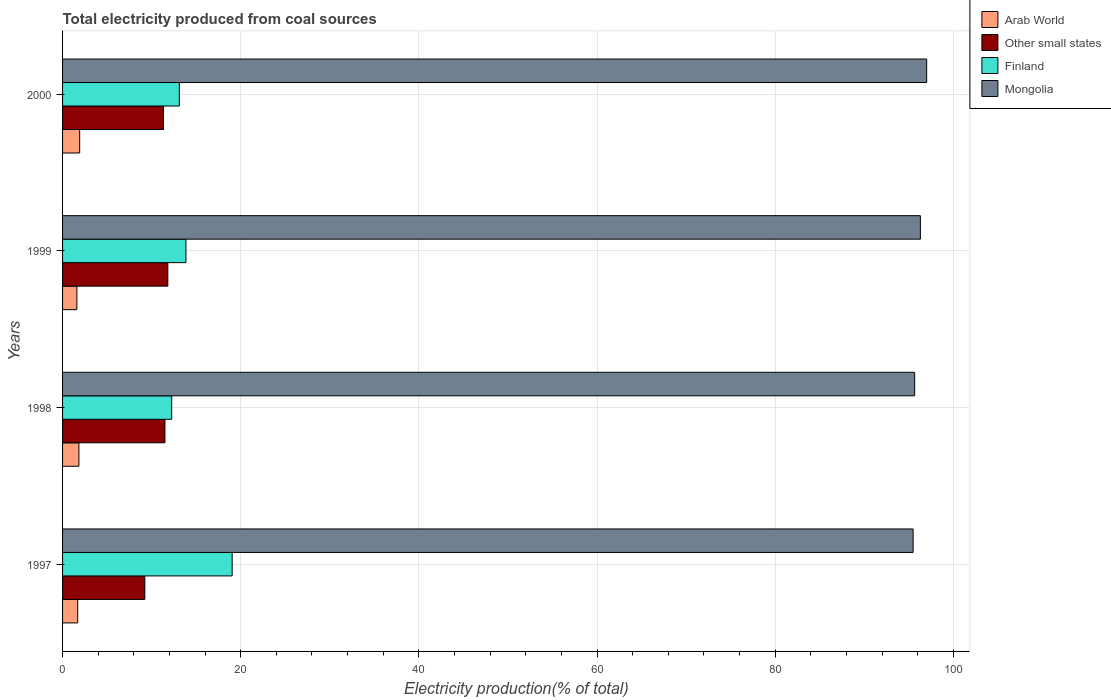How many different coloured bars are there?
Make the answer very short. 4. How many groups of bars are there?
Offer a terse response. 4. Are the number of bars per tick equal to the number of legend labels?
Provide a succinct answer. Yes. How many bars are there on the 1st tick from the bottom?
Provide a succinct answer. 4. What is the label of the 3rd group of bars from the top?
Your response must be concise. 1998. In how many cases, is the number of bars for a given year not equal to the number of legend labels?
Give a very brief answer. 0. What is the total electricity produced in Other small states in 1999?
Provide a short and direct response. 11.82. Across all years, what is the maximum total electricity produced in Finland?
Your answer should be compact. 19.04. Across all years, what is the minimum total electricity produced in Other small states?
Provide a succinct answer. 9.24. In which year was the total electricity produced in Arab World maximum?
Offer a terse response. 2000. In which year was the total electricity produced in Finland minimum?
Offer a terse response. 1998. What is the total total electricity produced in Other small states in the graph?
Make the answer very short. 43.88. What is the difference between the total electricity produced in Arab World in 1997 and that in 1998?
Your answer should be very brief. -0.14. What is the difference between the total electricity produced in Mongolia in 2000 and the total electricity produced in Finland in 1997?
Provide a short and direct response. 77.97. What is the average total electricity produced in Finland per year?
Your answer should be compact. 14.56. In the year 1997, what is the difference between the total electricity produced in Arab World and total electricity produced in Finland?
Give a very brief answer. -17.34. What is the ratio of the total electricity produced in Arab World in 1997 to that in 2000?
Provide a short and direct response. 0.88. Is the difference between the total electricity produced in Arab World in 1998 and 2000 greater than the difference between the total electricity produced in Finland in 1998 and 2000?
Give a very brief answer. Yes. What is the difference between the highest and the second highest total electricity produced in Other small states?
Provide a short and direct response. 0.32. What is the difference between the highest and the lowest total electricity produced in Finland?
Offer a terse response. 6.79. Is the sum of the total electricity produced in Mongolia in 1997 and 1998 greater than the maximum total electricity produced in Other small states across all years?
Keep it short and to the point. Yes. What does the 1st bar from the top in 2000 represents?
Provide a succinct answer. Mongolia. What does the 4th bar from the bottom in 2000 represents?
Provide a succinct answer. Mongolia. What is the difference between two consecutive major ticks on the X-axis?
Give a very brief answer. 20. Are the values on the major ticks of X-axis written in scientific E-notation?
Your response must be concise. No. Does the graph contain any zero values?
Ensure brevity in your answer.  No. Where does the legend appear in the graph?
Give a very brief answer. Top right. What is the title of the graph?
Give a very brief answer. Total electricity produced from coal sources. What is the Electricity production(% of total) in Arab World in 1997?
Offer a very short reply. 1.7. What is the Electricity production(% of total) in Other small states in 1997?
Provide a short and direct response. 9.24. What is the Electricity production(% of total) in Finland in 1997?
Your answer should be very brief. 19.04. What is the Electricity production(% of total) in Mongolia in 1997?
Your answer should be compact. 95.49. What is the Electricity production(% of total) of Arab World in 1998?
Keep it short and to the point. 1.83. What is the Electricity production(% of total) in Other small states in 1998?
Ensure brevity in your answer.  11.5. What is the Electricity production(% of total) in Finland in 1998?
Give a very brief answer. 12.25. What is the Electricity production(% of total) of Mongolia in 1998?
Offer a terse response. 95.66. What is the Electricity production(% of total) in Arab World in 1999?
Give a very brief answer. 1.61. What is the Electricity production(% of total) in Other small states in 1999?
Keep it short and to the point. 11.82. What is the Electricity production(% of total) of Finland in 1999?
Offer a terse response. 13.85. What is the Electricity production(% of total) in Mongolia in 1999?
Give a very brief answer. 96.31. What is the Electricity production(% of total) of Arab World in 2000?
Your response must be concise. 1.92. What is the Electricity production(% of total) in Other small states in 2000?
Your response must be concise. 11.33. What is the Electricity production(% of total) of Finland in 2000?
Your answer should be very brief. 13.11. What is the Electricity production(% of total) in Mongolia in 2000?
Offer a terse response. 97.01. Across all years, what is the maximum Electricity production(% of total) in Arab World?
Your answer should be compact. 1.92. Across all years, what is the maximum Electricity production(% of total) in Other small states?
Offer a terse response. 11.82. Across all years, what is the maximum Electricity production(% of total) of Finland?
Provide a succinct answer. 19.04. Across all years, what is the maximum Electricity production(% of total) of Mongolia?
Provide a short and direct response. 97.01. Across all years, what is the minimum Electricity production(% of total) in Arab World?
Your answer should be compact. 1.61. Across all years, what is the minimum Electricity production(% of total) of Other small states?
Provide a short and direct response. 9.24. Across all years, what is the minimum Electricity production(% of total) of Finland?
Make the answer very short. 12.25. Across all years, what is the minimum Electricity production(% of total) in Mongolia?
Offer a very short reply. 95.49. What is the total Electricity production(% of total) of Arab World in the graph?
Your response must be concise. 7.06. What is the total Electricity production(% of total) in Other small states in the graph?
Your answer should be very brief. 43.88. What is the total Electricity production(% of total) in Finland in the graph?
Provide a short and direct response. 58.25. What is the total Electricity production(% of total) of Mongolia in the graph?
Offer a very short reply. 384.47. What is the difference between the Electricity production(% of total) in Arab World in 1997 and that in 1998?
Provide a succinct answer. -0.14. What is the difference between the Electricity production(% of total) in Other small states in 1997 and that in 1998?
Keep it short and to the point. -2.26. What is the difference between the Electricity production(% of total) of Finland in 1997 and that in 1998?
Provide a short and direct response. 6.79. What is the difference between the Electricity production(% of total) of Mongolia in 1997 and that in 1998?
Give a very brief answer. -0.17. What is the difference between the Electricity production(% of total) of Arab World in 1997 and that in 1999?
Offer a very short reply. 0.09. What is the difference between the Electricity production(% of total) of Other small states in 1997 and that in 1999?
Make the answer very short. -2.58. What is the difference between the Electricity production(% of total) in Finland in 1997 and that in 1999?
Ensure brevity in your answer.  5.19. What is the difference between the Electricity production(% of total) in Mongolia in 1997 and that in 1999?
Provide a succinct answer. -0.81. What is the difference between the Electricity production(% of total) in Arab World in 1997 and that in 2000?
Keep it short and to the point. -0.22. What is the difference between the Electricity production(% of total) of Other small states in 1997 and that in 2000?
Offer a very short reply. -2.09. What is the difference between the Electricity production(% of total) in Finland in 1997 and that in 2000?
Offer a very short reply. 5.93. What is the difference between the Electricity production(% of total) of Mongolia in 1997 and that in 2000?
Your answer should be very brief. -1.52. What is the difference between the Electricity production(% of total) in Arab World in 1998 and that in 1999?
Your response must be concise. 0.23. What is the difference between the Electricity production(% of total) in Other small states in 1998 and that in 1999?
Provide a succinct answer. -0.32. What is the difference between the Electricity production(% of total) in Finland in 1998 and that in 1999?
Make the answer very short. -1.6. What is the difference between the Electricity production(% of total) in Mongolia in 1998 and that in 1999?
Make the answer very short. -0.64. What is the difference between the Electricity production(% of total) of Arab World in 1998 and that in 2000?
Your answer should be very brief. -0.09. What is the difference between the Electricity production(% of total) in Other small states in 1998 and that in 2000?
Provide a short and direct response. 0.17. What is the difference between the Electricity production(% of total) in Finland in 1998 and that in 2000?
Your answer should be very brief. -0.86. What is the difference between the Electricity production(% of total) in Mongolia in 1998 and that in 2000?
Offer a terse response. -1.35. What is the difference between the Electricity production(% of total) in Arab World in 1999 and that in 2000?
Provide a short and direct response. -0.31. What is the difference between the Electricity production(% of total) of Other small states in 1999 and that in 2000?
Offer a terse response. 0.49. What is the difference between the Electricity production(% of total) in Finland in 1999 and that in 2000?
Your answer should be compact. 0.74. What is the difference between the Electricity production(% of total) of Mongolia in 1999 and that in 2000?
Provide a succinct answer. -0.71. What is the difference between the Electricity production(% of total) of Arab World in 1997 and the Electricity production(% of total) of Other small states in 1998?
Provide a short and direct response. -9.8. What is the difference between the Electricity production(% of total) in Arab World in 1997 and the Electricity production(% of total) in Finland in 1998?
Provide a succinct answer. -10.55. What is the difference between the Electricity production(% of total) in Arab World in 1997 and the Electricity production(% of total) in Mongolia in 1998?
Make the answer very short. -93.97. What is the difference between the Electricity production(% of total) of Other small states in 1997 and the Electricity production(% of total) of Finland in 1998?
Provide a succinct answer. -3.01. What is the difference between the Electricity production(% of total) of Other small states in 1997 and the Electricity production(% of total) of Mongolia in 1998?
Keep it short and to the point. -86.43. What is the difference between the Electricity production(% of total) in Finland in 1997 and the Electricity production(% of total) in Mongolia in 1998?
Make the answer very short. -76.62. What is the difference between the Electricity production(% of total) in Arab World in 1997 and the Electricity production(% of total) in Other small states in 1999?
Keep it short and to the point. -10.12. What is the difference between the Electricity production(% of total) of Arab World in 1997 and the Electricity production(% of total) of Finland in 1999?
Provide a short and direct response. -12.15. What is the difference between the Electricity production(% of total) in Arab World in 1997 and the Electricity production(% of total) in Mongolia in 1999?
Keep it short and to the point. -94.61. What is the difference between the Electricity production(% of total) of Other small states in 1997 and the Electricity production(% of total) of Finland in 1999?
Your response must be concise. -4.62. What is the difference between the Electricity production(% of total) of Other small states in 1997 and the Electricity production(% of total) of Mongolia in 1999?
Offer a very short reply. -87.07. What is the difference between the Electricity production(% of total) in Finland in 1997 and the Electricity production(% of total) in Mongolia in 1999?
Your response must be concise. -77.27. What is the difference between the Electricity production(% of total) in Arab World in 1997 and the Electricity production(% of total) in Other small states in 2000?
Keep it short and to the point. -9.63. What is the difference between the Electricity production(% of total) of Arab World in 1997 and the Electricity production(% of total) of Finland in 2000?
Your response must be concise. -11.41. What is the difference between the Electricity production(% of total) of Arab World in 1997 and the Electricity production(% of total) of Mongolia in 2000?
Your answer should be compact. -95.32. What is the difference between the Electricity production(% of total) of Other small states in 1997 and the Electricity production(% of total) of Finland in 2000?
Keep it short and to the point. -3.87. What is the difference between the Electricity production(% of total) of Other small states in 1997 and the Electricity production(% of total) of Mongolia in 2000?
Keep it short and to the point. -87.78. What is the difference between the Electricity production(% of total) in Finland in 1997 and the Electricity production(% of total) in Mongolia in 2000?
Offer a very short reply. -77.97. What is the difference between the Electricity production(% of total) in Arab World in 1998 and the Electricity production(% of total) in Other small states in 1999?
Provide a succinct answer. -9.98. What is the difference between the Electricity production(% of total) in Arab World in 1998 and the Electricity production(% of total) in Finland in 1999?
Offer a terse response. -12.02. What is the difference between the Electricity production(% of total) of Arab World in 1998 and the Electricity production(% of total) of Mongolia in 1999?
Provide a succinct answer. -94.47. What is the difference between the Electricity production(% of total) of Other small states in 1998 and the Electricity production(% of total) of Finland in 1999?
Give a very brief answer. -2.36. What is the difference between the Electricity production(% of total) in Other small states in 1998 and the Electricity production(% of total) in Mongolia in 1999?
Give a very brief answer. -84.81. What is the difference between the Electricity production(% of total) in Finland in 1998 and the Electricity production(% of total) in Mongolia in 1999?
Make the answer very short. -84.06. What is the difference between the Electricity production(% of total) of Arab World in 1998 and the Electricity production(% of total) of Other small states in 2000?
Keep it short and to the point. -9.49. What is the difference between the Electricity production(% of total) of Arab World in 1998 and the Electricity production(% of total) of Finland in 2000?
Your answer should be very brief. -11.27. What is the difference between the Electricity production(% of total) of Arab World in 1998 and the Electricity production(% of total) of Mongolia in 2000?
Ensure brevity in your answer.  -95.18. What is the difference between the Electricity production(% of total) in Other small states in 1998 and the Electricity production(% of total) in Finland in 2000?
Keep it short and to the point. -1.61. What is the difference between the Electricity production(% of total) of Other small states in 1998 and the Electricity production(% of total) of Mongolia in 2000?
Offer a very short reply. -85.52. What is the difference between the Electricity production(% of total) of Finland in 1998 and the Electricity production(% of total) of Mongolia in 2000?
Provide a short and direct response. -84.76. What is the difference between the Electricity production(% of total) in Arab World in 1999 and the Electricity production(% of total) in Other small states in 2000?
Your answer should be very brief. -9.72. What is the difference between the Electricity production(% of total) of Arab World in 1999 and the Electricity production(% of total) of Finland in 2000?
Ensure brevity in your answer.  -11.5. What is the difference between the Electricity production(% of total) of Arab World in 1999 and the Electricity production(% of total) of Mongolia in 2000?
Offer a very short reply. -95.41. What is the difference between the Electricity production(% of total) of Other small states in 1999 and the Electricity production(% of total) of Finland in 2000?
Provide a succinct answer. -1.29. What is the difference between the Electricity production(% of total) of Other small states in 1999 and the Electricity production(% of total) of Mongolia in 2000?
Give a very brief answer. -85.19. What is the difference between the Electricity production(% of total) of Finland in 1999 and the Electricity production(% of total) of Mongolia in 2000?
Offer a very short reply. -83.16. What is the average Electricity production(% of total) of Arab World per year?
Provide a succinct answer. 1.76. What is the average Electricity production(% of total) of Other small states per year?
Your answer should be very brief. 10.97. What is the average Electricity production(% of total) of Finland per year?
Make the answer very short. 14.56. What is the average Electricity production(% of total) of Mongolia per year?
Provide a succinct answer. 96.12. In the year 1997, what is the difference between the Electricity production(% of total) in Arab World and Electricity production(% of total) in Other small states?
Give a very brief answer. -7.54. In the year 1997, what is the difference between the Electricity production(% of total) of Arab World and Electricity production(% of total) of Finland?
Provide a succinct answer. -17.34. In the year 1997, what is the difference between the Electricity production(% of total) in Arab World and Electricity production(% of total) in Mongolia?
Give a very brief answer. -93.79. In the year 1997, what is the difference between the Electricity production(% of total) of Other small states and Electricity production(% of total) of Finland?
Give a very brief answer. -9.8. In the year 1997, what is the difference between the Electricity production(% of total) in Other small states and Electricity production(% of total) in Mongolia?
Ensure brevity in your answer.  -86.26. In the year 1997, what is the difference between the Electricity production(% of total) of Finland and Electricity production(% of total) of Mongolia?
Keep it short and to the point. -76.45. In the year 1998, what is the difference between the Electricity production(% of total) in Arab World and Electricity production(% of total) in Other small states?
Keep it short and to the point. -9.66. In the year 1998, what is the difference between the Electricity production(% of total) in Arab World and Electricity production(% of total) in Finland?
Your answer should be very brief. -10.41. In the year 1998, what is the difference between the Electricity production(% of total) of Arab World and Electricity production(% of total) of Mongolia?
Ensure brevity in your answer.  -93.83. In the year 1998, what is the difference between the Electricity production(% of total) in Other small states and Electricity production(% of total) in Finland?
Provide a succinct answer. -0.75. In the year 1998, what is the difference between the Electricity production(% of total) in Other small states and Electricity production(% of total) in Mongolia?
Your response must be concise. -84.17. In the year 1998, what is the difference between the Electricity production(% of total) in Finland and Electricity production(% of total) in Mongolia?
Keep it short and to the point. -83.41. In the year 1999, what is the difference between the Electricity production(% of total) of Arab World and Electricity production(% of total) of Other small states?
Ensure brevity in your answer.  -10.21. In the year 1999, what is the difference between the Electricity production(% of total) of Arab World and Electricity production(% of total) of Finland?
Your answer should be very brief. -12.24. In the year 1999, what is the difference between the Electricity production(% of total) of Arab World and Electricity production(% of total) of Mongolia?
Offer a very short reply. -94.7. In the year 1999, what is the difference between the Electricity production(% of total) of Other small states and Electricity production(% of total) of Finland?
Provide a short and direct response. -2.03. In the year 1999, what is the difference between the Electricity production(% of total) in Other small states and Electricity production(% of total) in Mongolia?
Your answer should be very brief. -84.49. In the year 1999, what is the difference between the Electricity production(% of total) of Finland and Electricity production(% of total) of Mongolia?
Your answer should be very brief. -82.45. In the year 2000, what is the difference between the Electricity production(% of total) in Arab World and Electricity production(% of total) in Other small states?
Provide a short and direct response. -9.41. In the year 2000, what is the difference between the Electricity production(% of total) of Arab World and Electricity production(% of total) of Finland?
Provide a succinct answer. -11.19. In the year 2000, what is the difference between the Electricity production(% of total) in Arab World and Electricity production(% of total) in Mongolia?
Make the answer very short. -95.09. In the year 2000, what is the difference between the Electricity production(% of total) of Other small states and Electricity production(% of total) of Finland?
Your answer should be very brief. -1.78. In the year 2000, what is the difference between the Electricity production(% of total) of Other small states and Electricity production(% of total) of Mongolia?
Give a very brief answer. -85.68. In the year 2000, what is the difference between the Electricity production(% of total) of Finland and Electricity production(% of total) of Mongolia?
Keep it short and to the point. -83.9. What is the ratio of the Electricity production(% of total) of Arab World in 1997 to that in 1998?
Make the answer very short. 0.93. What is the ratio of the Electricity production(% of total) in Other small states in 1997 to that in 1998?
Your response must be concise. 0.8. What is the ratio of the Electricity production(% of total) in Finland in 1997 to that in 1998?
Provide a succinct answer. 1.55. What is the ratio of the Electricity production(% of total) in Arab World in 1997 to that in 1999?
Give a very brief answer. 1.06. What is the ratio of the Electricity production(% of total) in Other small states in 1997 to that in 1999?
Your response must be concise. 0.78. What is the ratio of the Electricity production(% of total) of Finland in 1997 to that in 1999?
Provide a short and direct response. 1.37. What is the ratio of the Electricity production(% of total) in Arab World in 1997 to that in 2000?
Make the answer very short. 0.88. What is the ratio of the Electricity production(% of total) of Other small states in 1997 to that in 2000?
Ensure brevity in your answer.  0.82. What is the ratio of the Electricity production(% of total) in Finland in 1997 to that in 2000?
Provide a succinct answer. 1.45. What is the ratio of the Electricity production(% of total) in Mongolia in 1997 to that in 2000?
Provide a succinct answer. 0.98. What is the ratio of the Electricity production(% of total) of Arab World in 1998 to that in 1999?
Give a very brief answer. 1.14. What is the ratio of the Electricity production(% of total) in Other small states in 1998 to that in 1999?
Offer a very short reply. 0.97. What is the ratio of the Electricity production(% of total) of Finland in 1998 to that in 1999?
Provide a succinct answer. 0.88. What is the ratio of the Electricity production(% of total) of Mongolia in 1998 to that in 1999?
Provide a succinct answer. 0.99. What is the ratio of the Electricity production(% of total) in Arab World in 1998 to that in 2000?
Give a very brief answer. 0.96. What is the ratio of the Electricity production(% of total) in Other small states in 1998 to that in 2000?
Make the answer very short. 1.01. What is the ratio of the Electricity production(% of total) in Finland in 1998 to that in 2000?
Give a very brief answer. 0.93. What is the ratio of the Electricity production(% of total) in Mongolia in 1998 to that in 2000?
Offer a very short reply. 0.99. What is the ratio of the Electricity production(% of total) of Arab World in 1999 to that in 2000?
Offer a terse response. 0.84. What is the ratio of the Electricity production(% of total) of Other small states in 1999 to that in 2000?
Make the answer very short. 1.04. What is the ratio of the Electricity production(% of total) in Finland in 1999 to that in 2000?
Provide a succinct answer. 1.06. What is the difference between the highest and the second highest Electricity production(% of total) in Arab World?
Give a very brief answer. 0.09. What is the difference between the highest and the second highest Electricity production(% of total) in Other small states?
Offer a very short reply. 0.32. What is the difference between the highest and the second highest Electricity production(% of total) of Finland?
Give a very brief answer. 5.19. What is the difference between the highest and the second highest Electricity production(% of total) in Mongolia?
Make the answer very short. 0.71. What is the difference between the highest and the lowest Electricity production(% of total) of Arab World?
Your response must be concise. 0.31. What is the difference between the highest and the lowest Electricity production(% of total) of Other small states?
Give a very brief answer. 2.58. What is the difference between the highest and the lowest Electricity production(% of total) of Finland?
Your answer should be very brief. 6.79. What is the difference between the highest and the lowest Electricity production(% of total) in Mongolia?
Offer a very short reply. 1.52. 